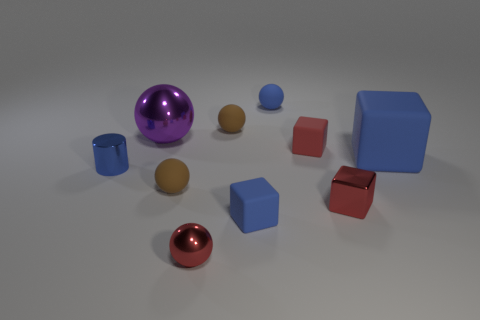Do the tiny metallic cube and the small metal ball have the same color?
Your answer should be very brief. Yes. There is a red rubber object that is the same size as the cylinder; what shape is it?
Provide a short and direct response. Cube. Are there fewer tiny balls than tiny objects?
Your response must be concise. Yes. There is a small rubber sphere that is left of the small metallic ball; is there a cylinder that is in front of it?
Give a very brief answer. No. There is a blue matte block that is behind the metallic object that is to the left of the purple ball; is there a tiny blue metal cylinder that is behind it?
Provide a succinct answer. No. There is a tiny brown object that is behind the blue cylinder; is it the same shape as the shiny thing that is behind the big blue object?
Make the answer very short. Yes. There is a large block that is the same material as the blue sphere; what is its color?
Offer a very short reply. Blue. Are there fewer rubber blocks that are left of the small blue cylinder than tiny purple metallic spheres?
Ensure brevity in your answer.  No. What size is the purple metallic thing that is left of the small brown object behind the small rubber object left of the small metal sphere?
Provide a short and direct response. Large. Is the material of the tiny blue object behind the red rubber object the same as the purple object?
Provide a short and direct response. No. 